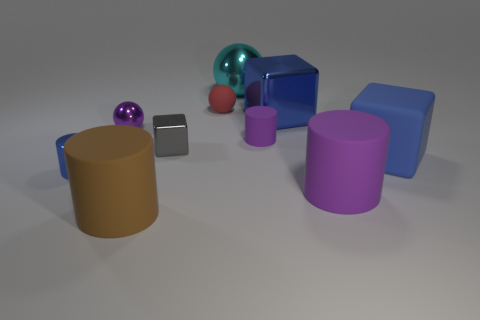There is a tiny metallic thing that is the same color as the matte cube; what is its shape?
Keep it short and to the point. Cylinder. There is a rubber thing left of the small rubber sphere; what is its shape?
Ensure brevity in your answer.  Cylinder. What shape is the purple object right of the tiny rubber object that is on the right side of the large cyan metallic sphere?
Your response must be concise. Cylinder. Are there any other large metal objects that have the same shape as the large brown thing?
Provide a short and direct response. No. What is the shape of the brown object that is the same size as the cyan shiny thing?
Provide a succinct answer. Cylinder. Are there any brown cylinders behind the big shiny thing right of the metal sphere that is behind the tiny red ball?
Offer a terse response. No. Are there any blue rubber cubes that have the same size as the gray metallic thing?
Offer a terse response. No. What is the size of the purple object that is left of the cyan sphere?
Your response must be concise. Small. There is a metal block that is left of the purple matte thing that is behind the purple rubber thing that is in front of the small blue metallic object; what color is it?
Make the answer very short. Gray. What is the color of the tiny object that is to the right of the large metal ball on the right side of the big brown cylinder?
Offer a very short reply. Purple. 